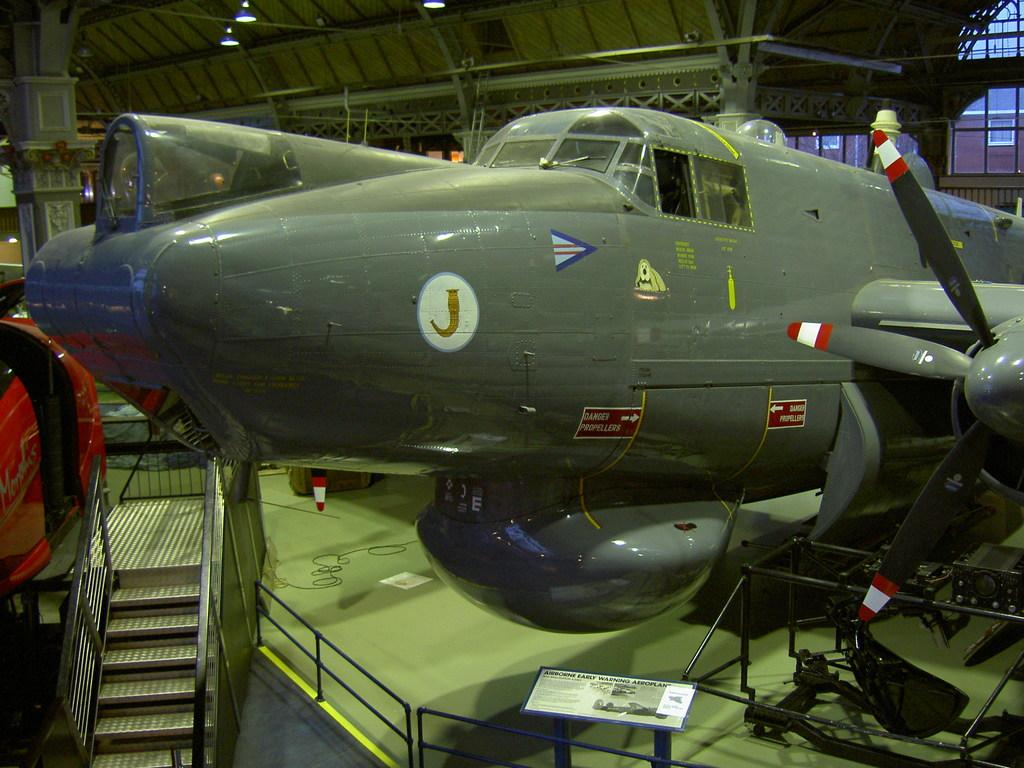What is the main subject of the image? The main subject of the image is an aeroplane. What other objects can be seen in the image? There is a staircase, a board with text, a ceiling with rods, and a pillar visible in the image. Reasoning: Let' Let's think step by step in order to produce the conversation. We start by identifying the main subject of the image, which is the aeroplane. Then, we describe the other objects that are present in the image, ensuring that each question can be answered definitively with the information given. We avoid yes/no questions and ensure that the language is simple and clear. Absurd Question/Answer: What type of ball is being used for pleasure in the image? There is no ball present in the image, and no pleasure-related activities are depicted. 